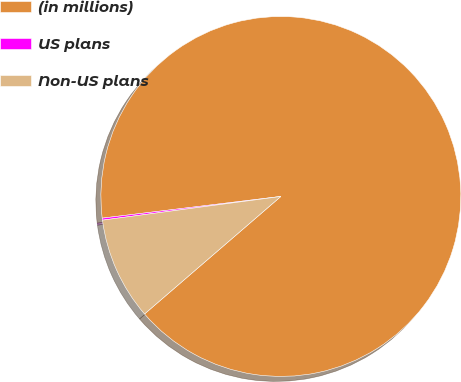<chart> <loc_0><loc_0><loc_500><loc_500><pie_chart><fcel>(in millions)<fcel>US plans<fcel>Non-US plans<nl><fcel>90.6%<fcel>0.18%<fcel>9.22%<nl></chart> 